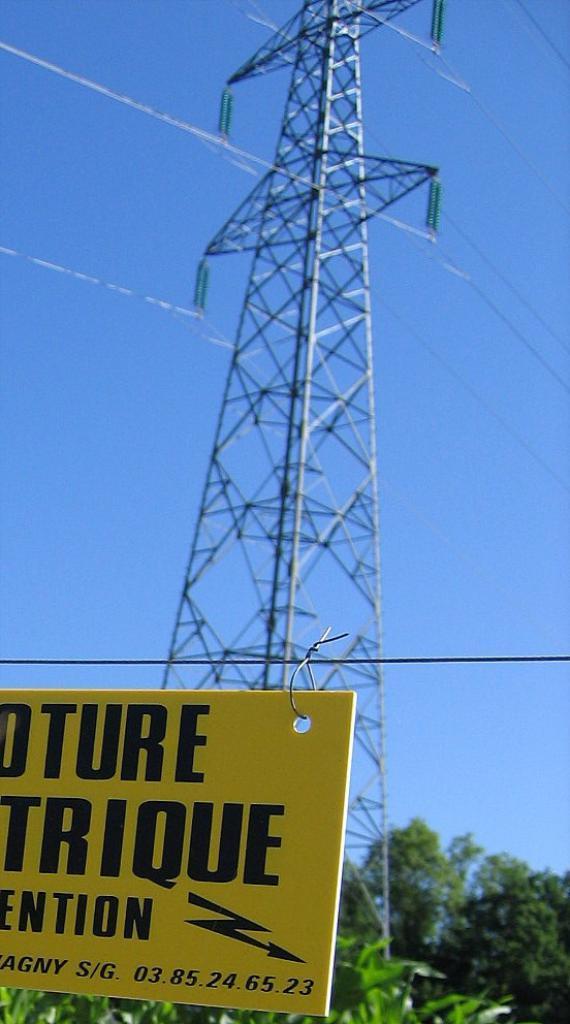Can you describe this image briefly? In this image, we can see a yellow board. Here we can see some text on the board. Background there is a transmission tower with wires. At the bottom of the image, we can see few trees. Here there is a sky. 